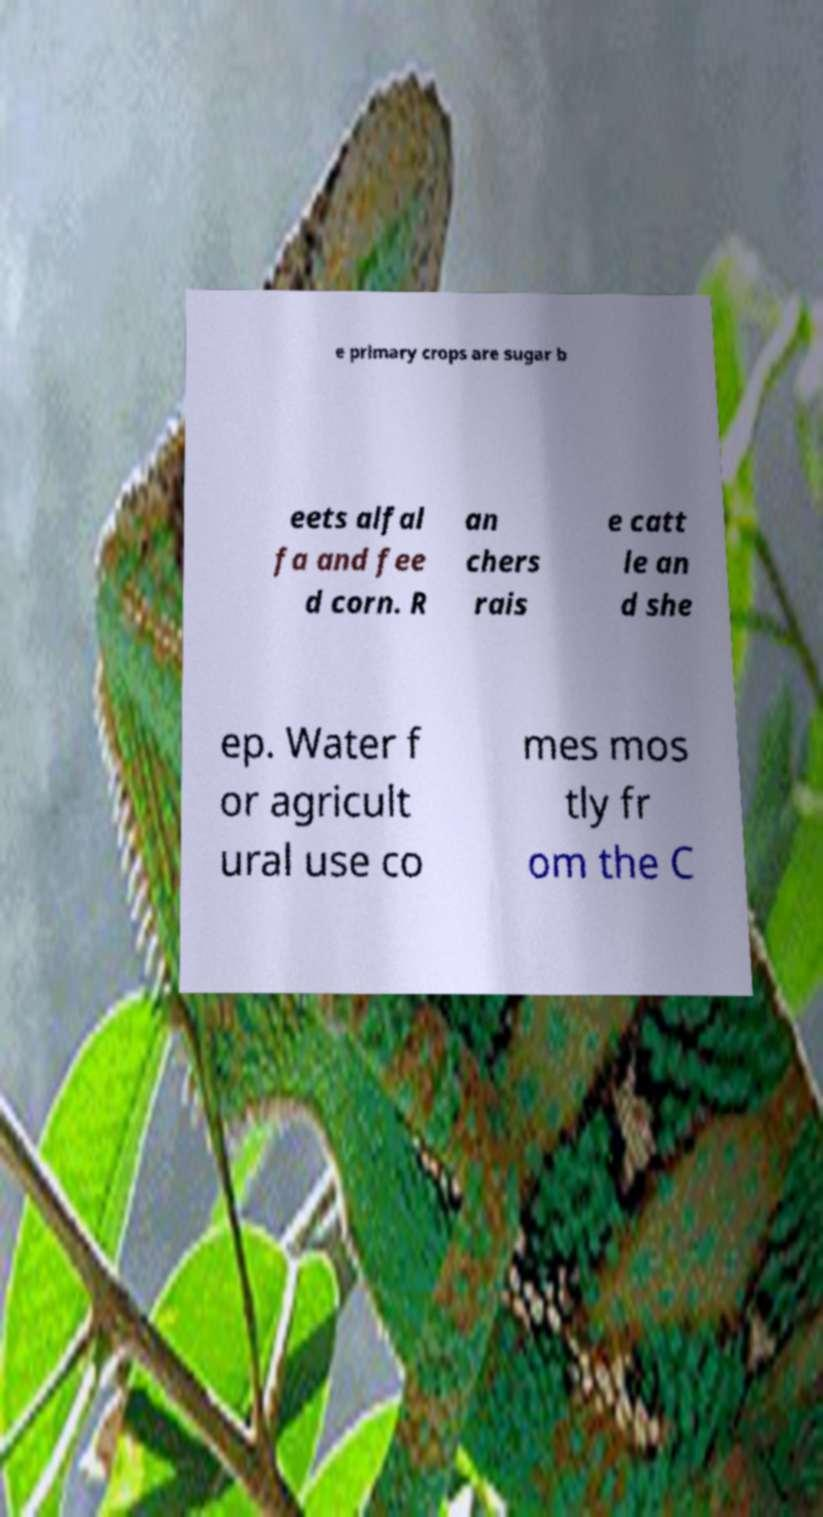I need the written content from this picture converted into text. Can you do that? e primary crops are sugar b eets alfal fa and fee d corn. R an chers rais e catt le an d she ep. Water f or agricult ural use co mes mos tly fr om the C 